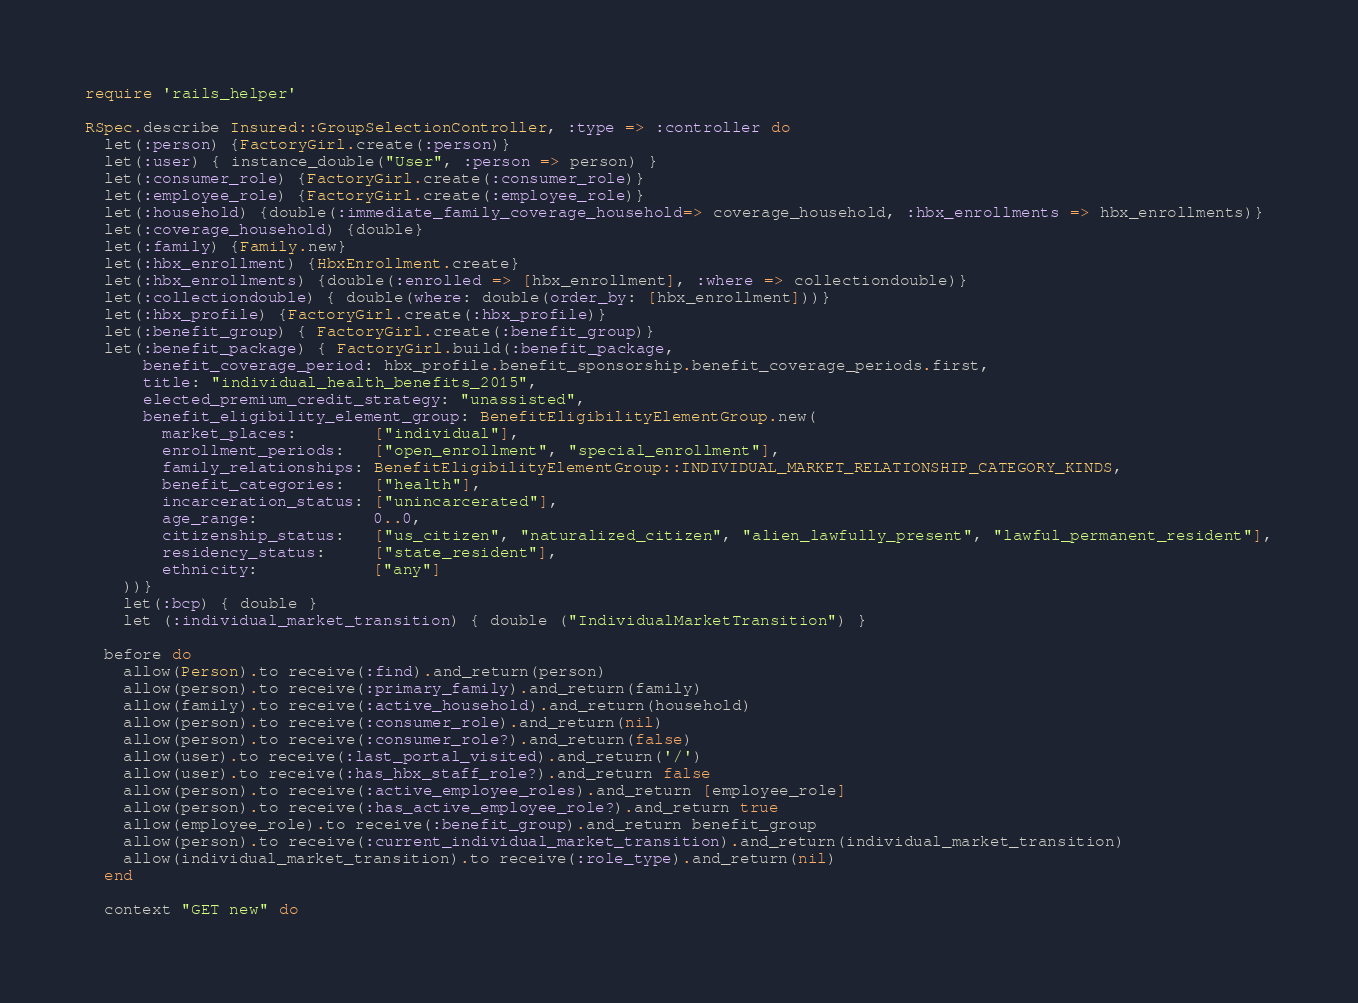Convert code to text. <code><loc_0><loc_0><loc_500><loc_500><_Ruby_>require 'rails_helper'

RSpec.describe Insured::GroupSelectionController, :type => :controller do
  let(:person) {FactoryGirl.create(:person)}
  let(:user) { instance_double("User", :person => person) }
  let(:consumer_role) {FactoryGirl.create(:consumer_role)}
  let(:employee_role) {FactoryGirl.create(:employee_role)}
  let(:household) {double(:immediate_family_coverage_household=> coverage_household, :hbx_enrollments => hbx_enrollments)}
  let(:coverage_household) {double}
  let(:family) {Family.new}
  let(:hbx_enrollment) {HbxEnrollment.create}
  let(:hbx_enrollments) {double(:enrolled => [hbx_enrollment], :where => collectiondouble)}
  let(:collectiondouble) { double(where: double(order_by: [hbx_enrollment]))}
  let(:hbx_profile) {FactoryGirl.create(:hbx_profile)}
  let(:benefit_group) { FactoryGirl.create(:benefit_group)}
  let(:benefit_package) { FactoryGirl.build(:benefit_package,
      benefit_coverage_period: hbx_profile.benefit_sponsorship.benefit_coverage_periods.first,
      title: "individual_health_benefits_2015",
      elected_premium_credit_strategy: "unassisted",
      benefit_eligibility_element_group: BenefitEligibilityElementGroup.new(
        market_places:        ["individual"],
        enrollment_periods:   ["open_enrollment", "special_enrollment"],
        family_relationships: BenefitEligibilityElementGroup::INDIVIDUAL_MARKET_RELATIONSHIP_CATEGORY_KINDS,
        benefit_categories:   ["health"],
        incarceration_status: ["unincarcerated"],
        age_range:            0..0,
        citizenship_status:   ["us_citizen", "naturalized_citizen", "alien_lawfully_present", "lawful_permanent_resident"],
        residency_status:     ["state_resident"],
        ethnicity:            ["any"]
    ))}
    let(:bcp) { double }
    let (:individual_market_transition) { double ("IndividualMarketTransition") }

  before do
    allow(Person).to receive(:find).and_return(person)
    allow(person).to receive(:primary_family).and_return(family)
    allow(family).to receive(:active_household).and_return(household)
    allow(person).to receive(:consumer_role).and_return(nil)
    allow(person).to receive(:consumer_role?).and_return(false)
    allow(user).to receive(:last_portal_visited).and_return('/')
    allow(user).to receive(:has_hbx_staff_role?).and_return false
    allow(person).to receive(:active_employee_roles).and_return [employee_role]
    allow(person).to receive(:has_active_employee_role?).and_return true
    allow(employee_role).to receive(:benefit_group).and_return benefit_group
    allow(person).to receive(:current_individual_market_transition).and_return(individual_market_transition)
    allow(individual_market_transition).to receive(:role_type).and_return(nil)
  end

  context "GET new" do</code> 